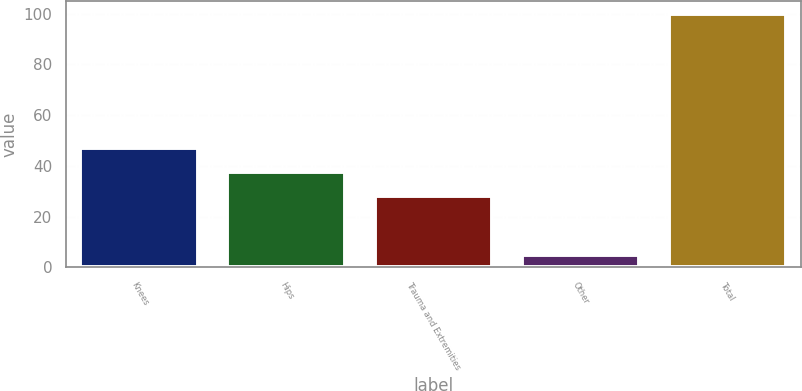Convert chart to OTSL. <chart><loc_0><loc_0><loc_500><loc_500><bar_chart><fcel>Knees<fcel>Hips<fcel>Trauma and Extremities<fcel>Other<fcel>Total<nl><fcel>47<fcel>37.5<fcel>28<fcel>5<fcel>100<nl></chart> 